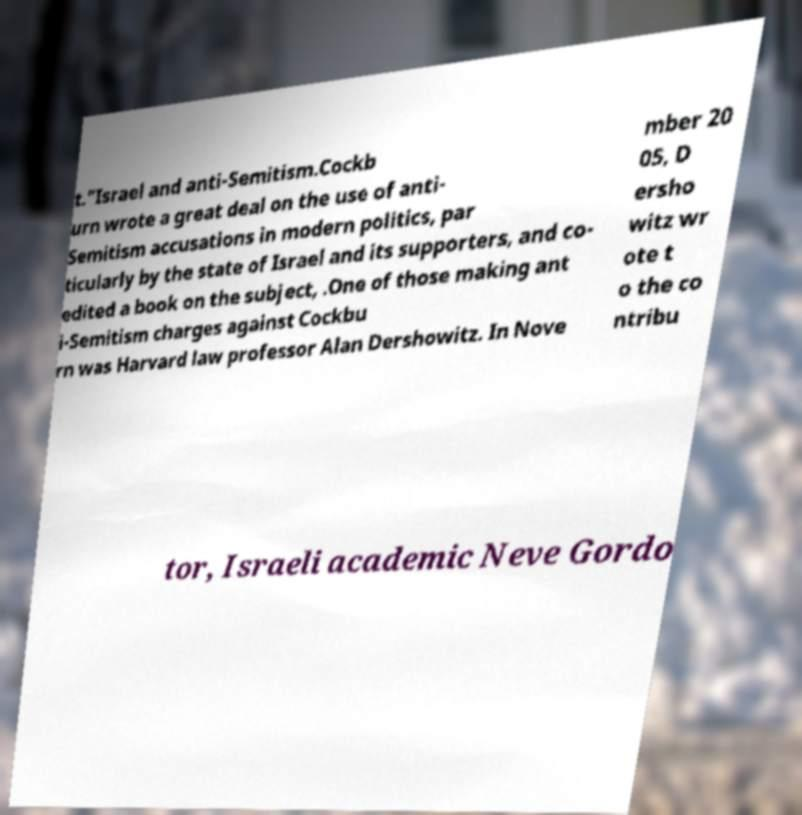Can you accurately transcribe the text from the provided image for me? t."Israel and anti-Semitism.Cockb urn wrote a great deal on the use of anti- Semitism accusations in modern politics, par ticularly by the state of Israel and its supporters, and co- edited a book on the subject, .One of those making ant i-Semitism charges against Cockbu rn was Harvard law professor Alan Dershowitz. In Nove mber 20 05, D ersho witz wr ote t o the co ntribu tor, Israeli academic Neve Gordo 